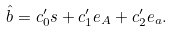Convert formula to latex. <formula><loc_0><loc_0><loc_500><loc_500>\hat { b } = c _ { 0 } ^ { \prime } { s } + c _ { 1 } ^ { \prime } { e } _ { A } + c _ { 2 } ^ { \prime } { e } _ { a } .</formula> 